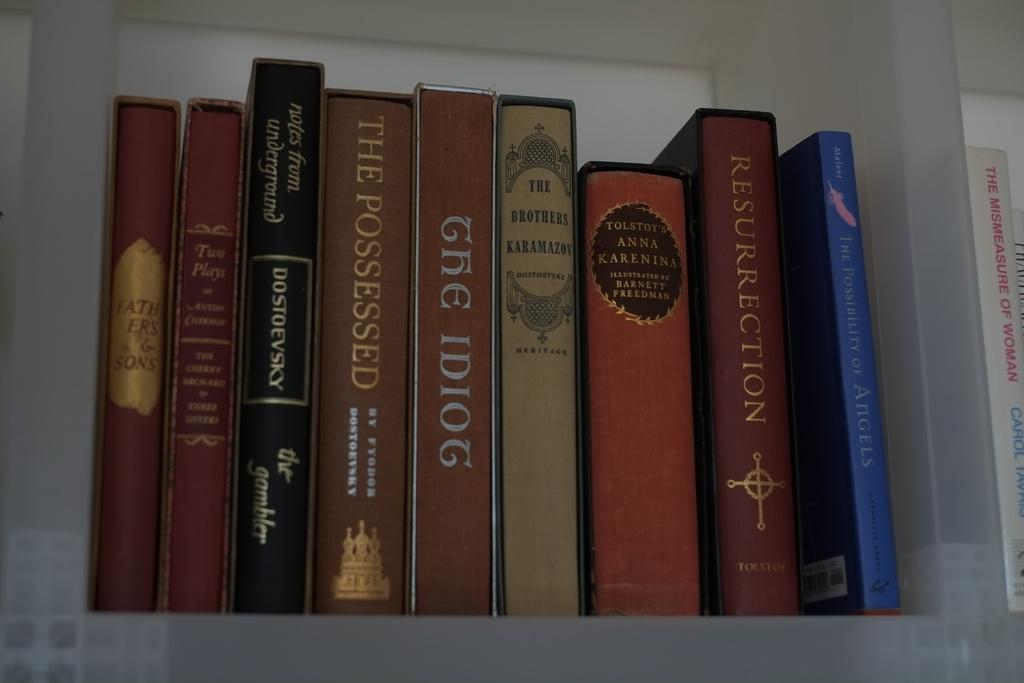<image>
Summarize the visual content of the image. nine boos arranged next to each other with different titles like "the idiog". 